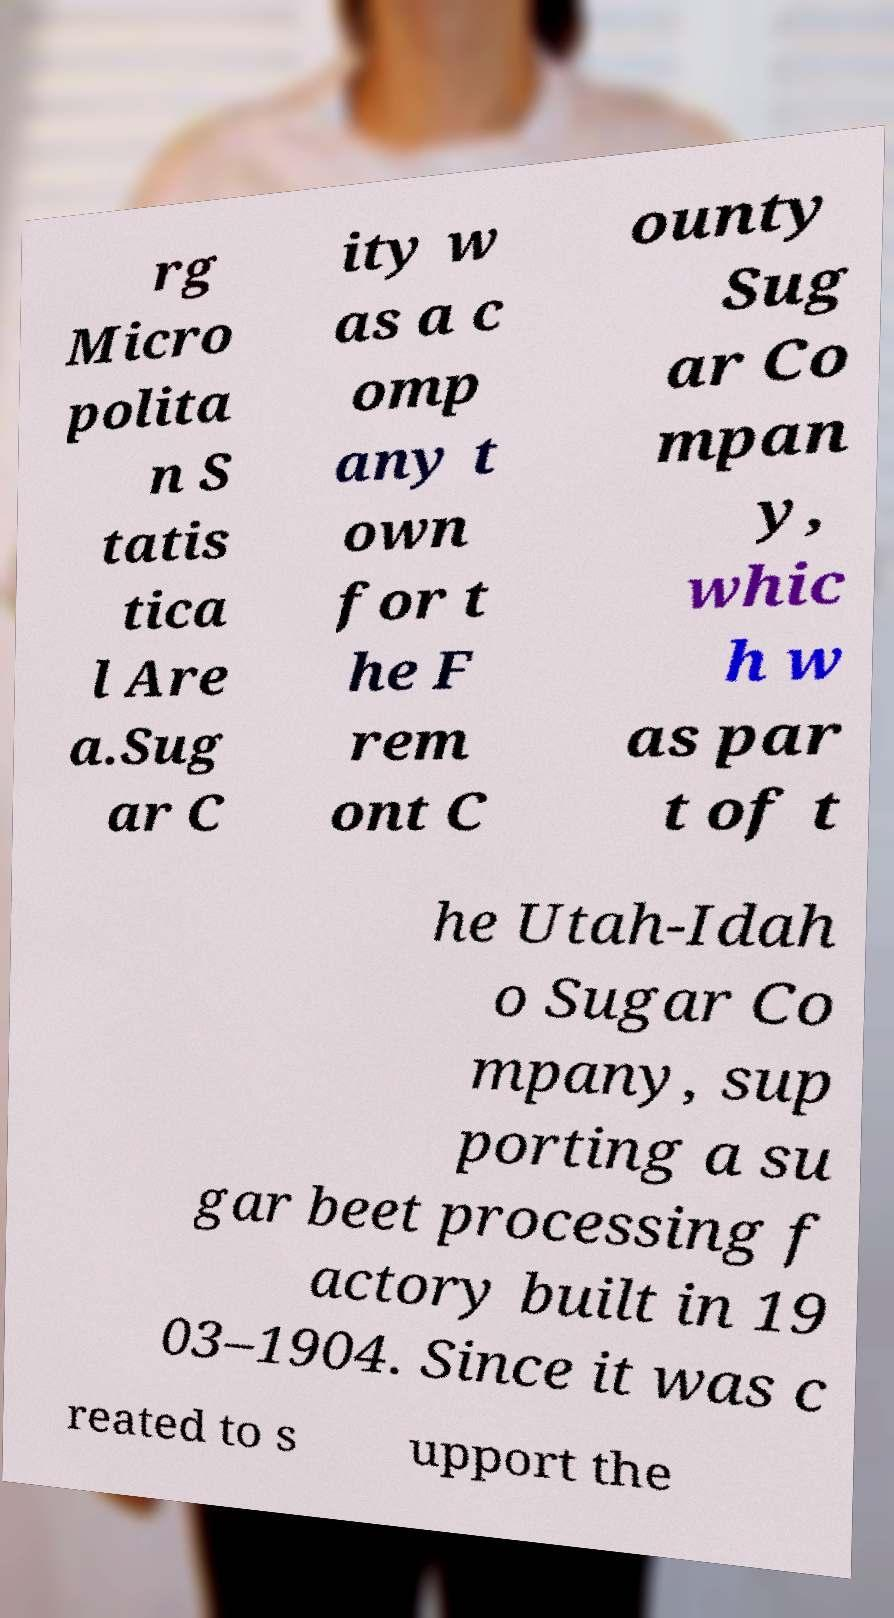Can you read and provide the text displayed in the image?This photo seems to have some interesting text. Can you extract and type it out for me? rg Micro polita n S tatis tica l Are a.Sug ar C ity w as a c omp any t own for t he F rem ont C ounty Sug ar Co mpan y, whic h w as par t of t he Utah-Idah o Sugar Co mpany, sup porting a su gar beet processing f actory built in 19 03–1904. Since it was c reated to s upport the 